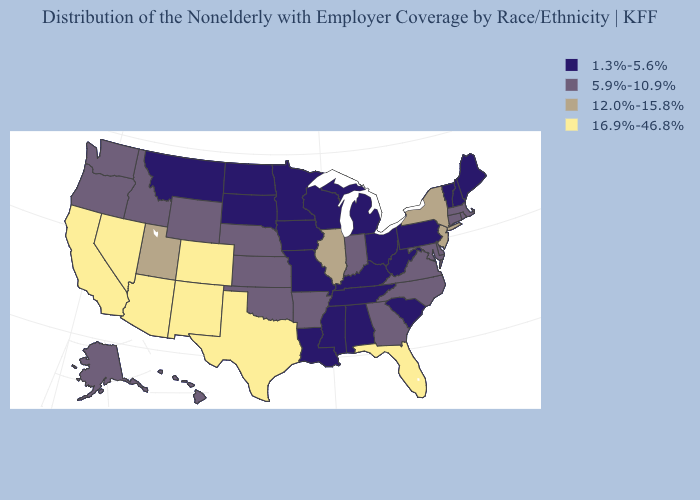What is the value of Maine?
Quick response, please. 1.3%-5.6%. Which states have the lowest value in the Northeast?
Concise answer only. Maine, New Hampshire, Pennsylvania, Vermont. Which states have the lowest value in the USA?
Quick response, please. Alabama, Iowa, Kentucky, Louisiana, Maine, Michigan, Minnesota, Mississippi, Missouri, Montana, New Hampshire, North Dakota, Ohio, Pennsylvania, South Carolina, South Dakota, Tennessee, Vermont, West Virginia, Wisconsin. What is the highest value in the USA?
Concise answer only. 16.9%-46.8%. Is the legend a continuous bar?
Quick response, please. No. Name the states that have a value in the range 12.0%-15.8%?
Concise answer only. Illinois, New Jersey, New York, Utah. Does West Virginia have a higher value than Colorado?
Write a very short answer. No. What is the highest value in states that border Delaware?
Concise answer only. 12.0%-15.8%. What is the highest value in the USA?
Give a very brief answer. 16.9%-46.8%. Name the states that have a value in the range 12.0%-15.8%?
Answer briefly. Illinois, New Jersey, New York, Utah. What is the value of Arkansas?
Give a very brief answer. 5.9%-10.9%. Name the states that have a value in the range 5.9%-10.9%?
Keep it brief. Alaska, Arkansas, Connecticut, Delaware, Georgia, Hawaii, Idaho, Indiana, Kansas, Maryland, Massachusetts, Nebraska, North Carolina, Oklahoma, Oregon, Rhode Island, Virginia, Washington, Wyoming. Does North Dakota have the same value as Texas?
Be succinct. No. What is the lowest value in the Northeast?
Be succinct. 1.3%-5.6%. 